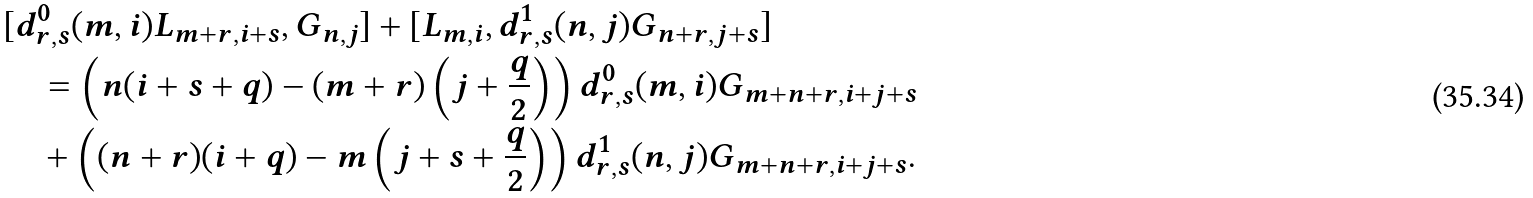<formula> <loc_0><loc_0><loc_500><loc_500>& [ d ^ { 0 } _ { r , s } ( m , i ) L _ { m + r , i + s } , G _ { n , j } ] + [ L _ { m , i } , d ^ { 1 } _ { r , s } ( n , j ) G _ { n + r , j + s } ] \\ & \quad = \left ( n ( i + s + q ) - ( m + r ) \left ( j + \frac { q } { 2 } \right ) \right ) d ^ { 0 } _ { r , s } ( m , i ) G _ { m + n + r , i + j + s } \\ & \quad + \left ( ( n + r ) ( i + q ) - m \left ( j + s + \frac { q } { 2 } \right ) \right ) d ^ { 1 } _ { r , s } ( n , j ) G _ { m + n + r , i + j + s } .</formula> 